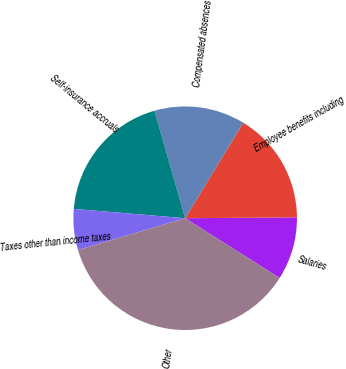Convert chart to OTSL. <chart><loc_0><loc_0><loc_500><loc_500><pie_chart><fcel>Salaries<fcel>Employee benefits including<fcel>Compensated absences<fcel>Self-insurance accruals<fcel>Taxes other than income taxes<fcel>Other<nl><fcel>9.1%<fcel>16.18%<fcel>13.13%<fcel>19.23%<fcel>5.92%<fcel>36.44%<nl></chart> 